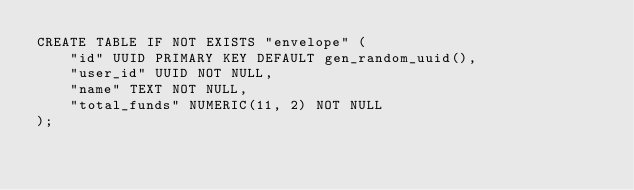<code> <loc_0><loc_0><loc_500><loc_500><_SQL_>CREATE TABLE IF NOT EXISTS "envelope" (
    "id" UUID PRIMARY KEY DEFAULT gen_random_uuid(),
    "user_id" UUID NOT NULL,
    "name" TEXT NOT NULL,
    "total_funds" NUMERIC(11, 2) NOT NULL
);
</code> 